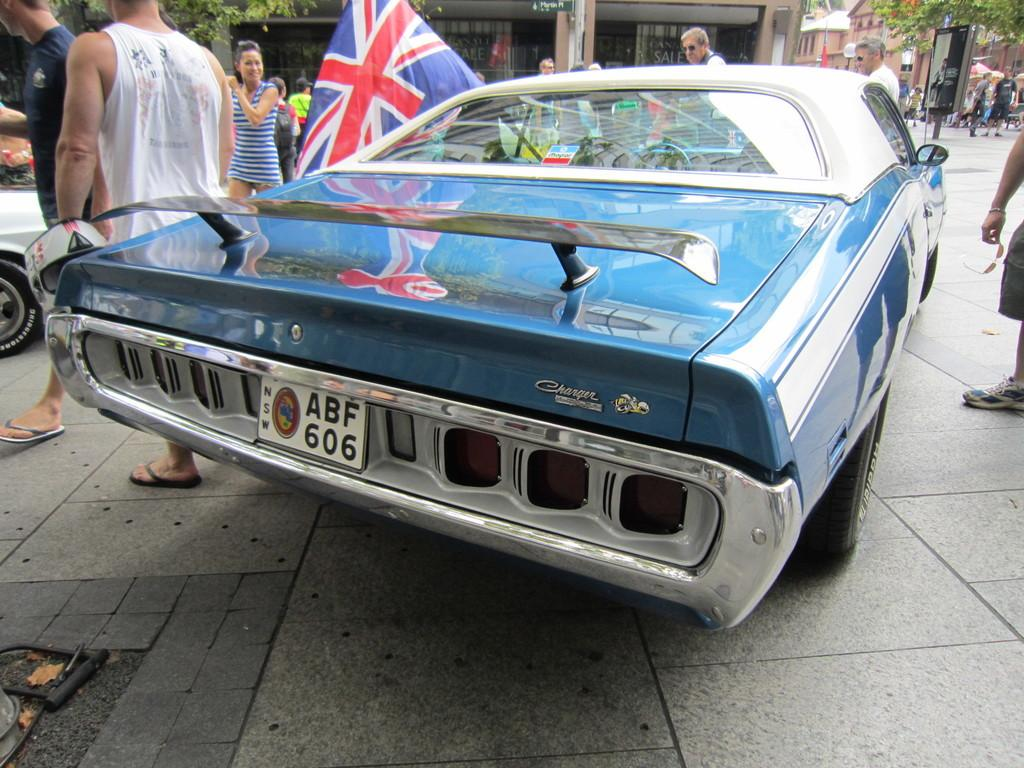<image>
Summarize the visual content of the image. A vintage blue Dodge Charger is on display at a car show in England. 